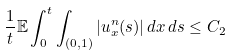Convert formula to latex. <formula><loc_0><loc_0><loc_500><loc_500>\frac { 1 } { t } \mathbb { E } \int _ { 0 } ^ { t } \int _ { ( 0 , 1 ) } | u ^ { n } _ { x } ( s ) | \, d x \, d s \leq C _ { 2 }</formula> 